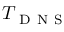<formula> <loc_0><loc_0><loc_500><loc_500>T _ { D N S }</formula> 